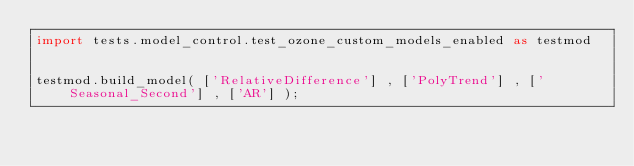Convert code to text. <code><loc_0><loc_0><loc_500><loc_500><_Python_>import tests.model_control.test_ozone_custom_models_enabled as testmod


testmod.build_model( ['RelativeDifference'] , ['PolyTrend'] , ['Seasonal_Second'] , ['AR'] );</code> 